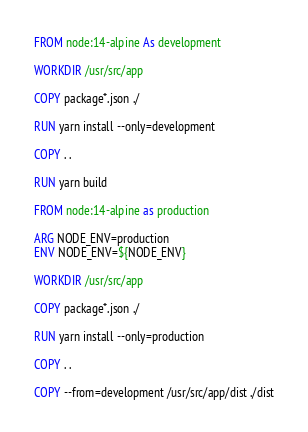<code> <loc_0><loc_0><loc_500><loc_500><_Dockerfile_>FROM node:14-alpine As development

WORKDIR /usr/src/app

COPY package*.json ./

RUN yarn install --only=development

COPY . .

RUN yarn build

FROM node:14-alpine as production

ARG NODE_ENV=production
ENV NODE_ENV=${NODE_ENV}

WORKDIR /usr/src/app

COPY package*.json ./

RUN yarn install --only=production

COPY . .

COPY --from=development /usr/src/app/dist ./dist
</code> 